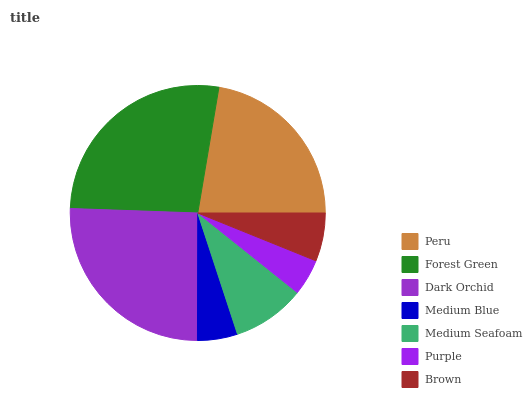Is Purple the minimum?
Answer yes or no. Yes. Is Forest Green the maximum?
Answer yes or no. Yes. Is Dark Orchid the minimum?
Answer yes or no. No. Is Dark Orchid the maximum?
Answer yes or no. No. Is Forest Green greater than Dark Orchid?
Answer yes or no. Yes. Is Dark Orchid less than Forest Green?
Answer yes or no. Yes. Is Dark Orchid greater than Forest Green?
Answer yes or no. No. Is Forest Green less than Dark Orchid?
Answer yes or no. No. Is Medium Seafoam the high median?
Answer yes or no. Yes. Is Medium Seafoam the low median?
Answer yes or no. Yes. Is Peru the high median?
Answer yes or no. No. Is Forest Green the low median?
Answer yes or no. No. 